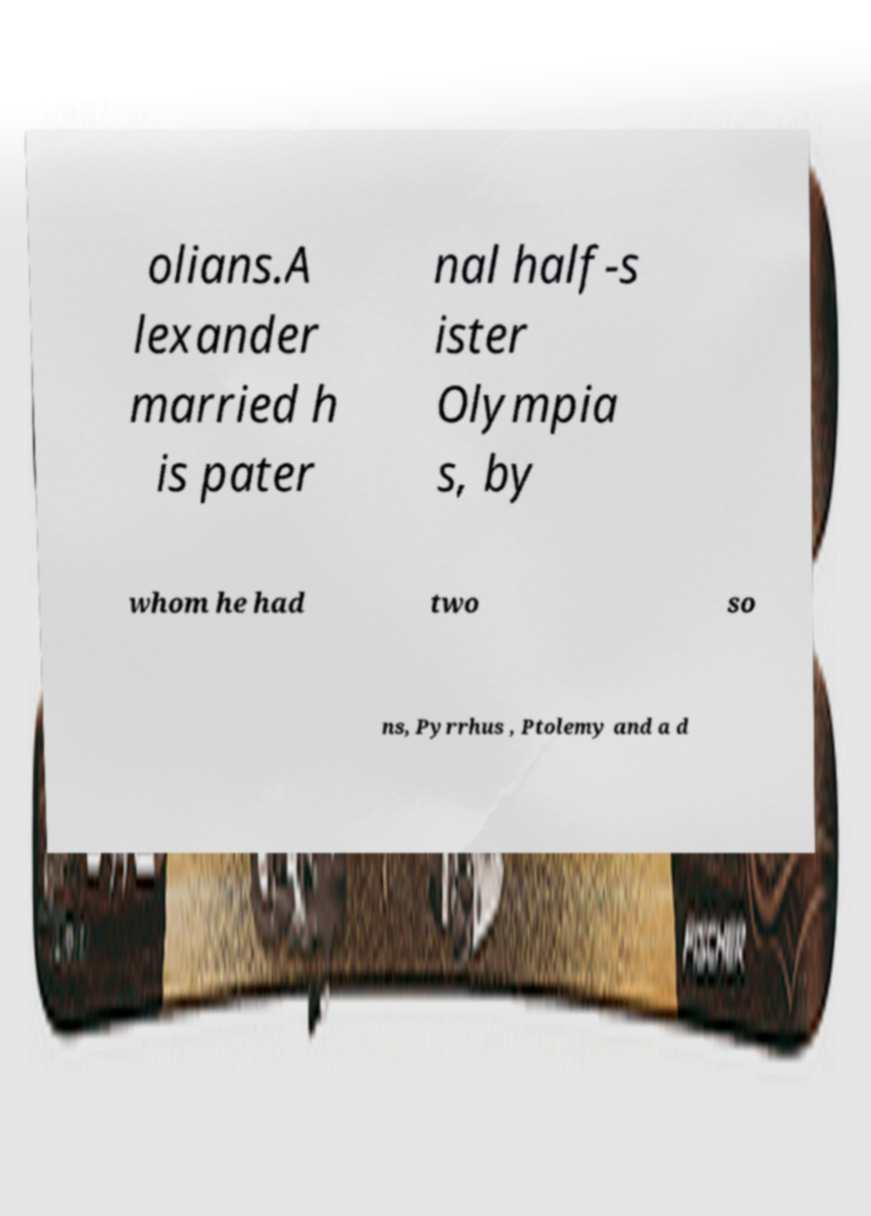Could you extract and type out the text from this image? olians.A lexander married h is pater nal half-s ister Olympia s, by whom he had two so ns, Pyrrhus , Ptolemy and a d 